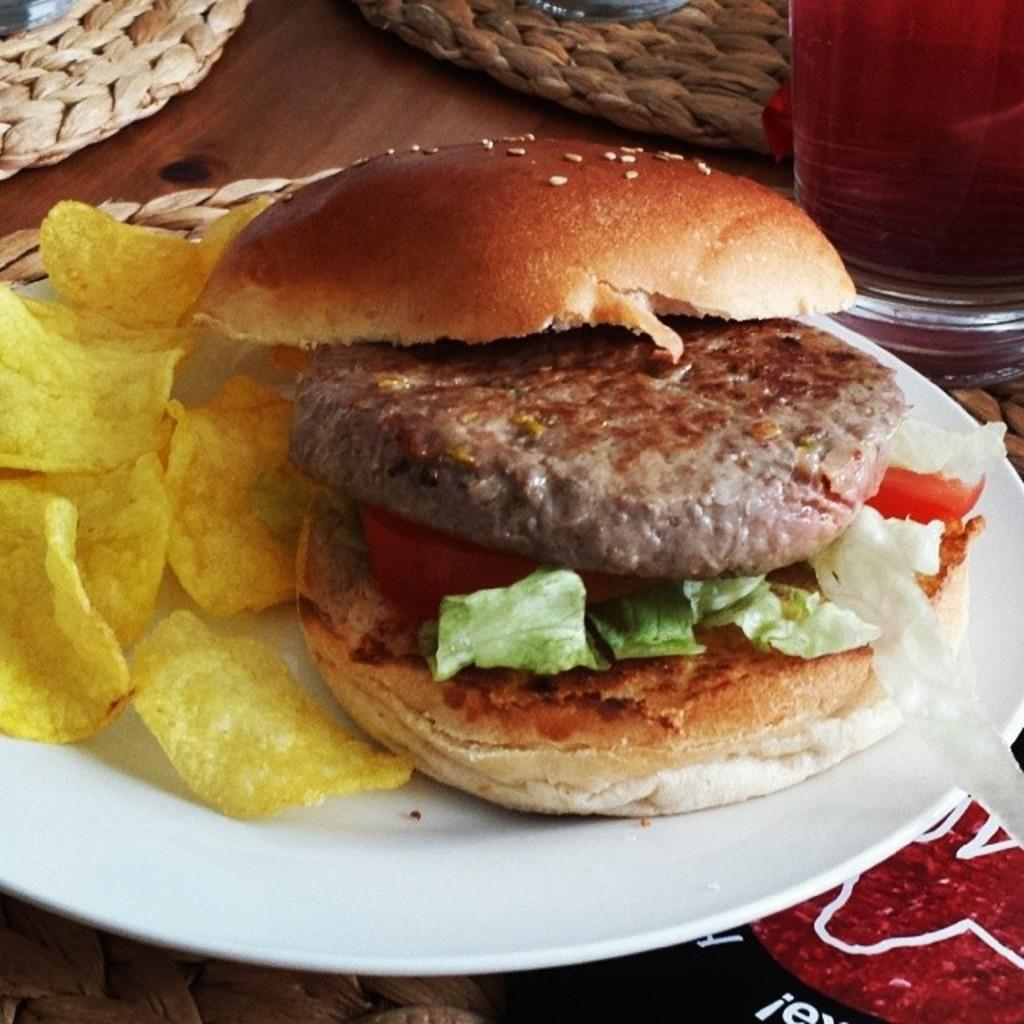What type of food is on the plate in the image? There is a Burger on a plate in the image. What other food item is on the plate with the Burger? There are chips on the plate in the image. Where is the plate located in the image? The plate is on a table mat in the image. What can be seen in the background of the image? There is a glass with liquid in the background of the image, and there are table mats on the table. What note is the beggar playing in the image? There is no beggar or musical instrument present in the image. 